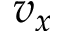<formula> <loc_0><loc_0><loc_500><loc_500>v _ { x }</formula> 